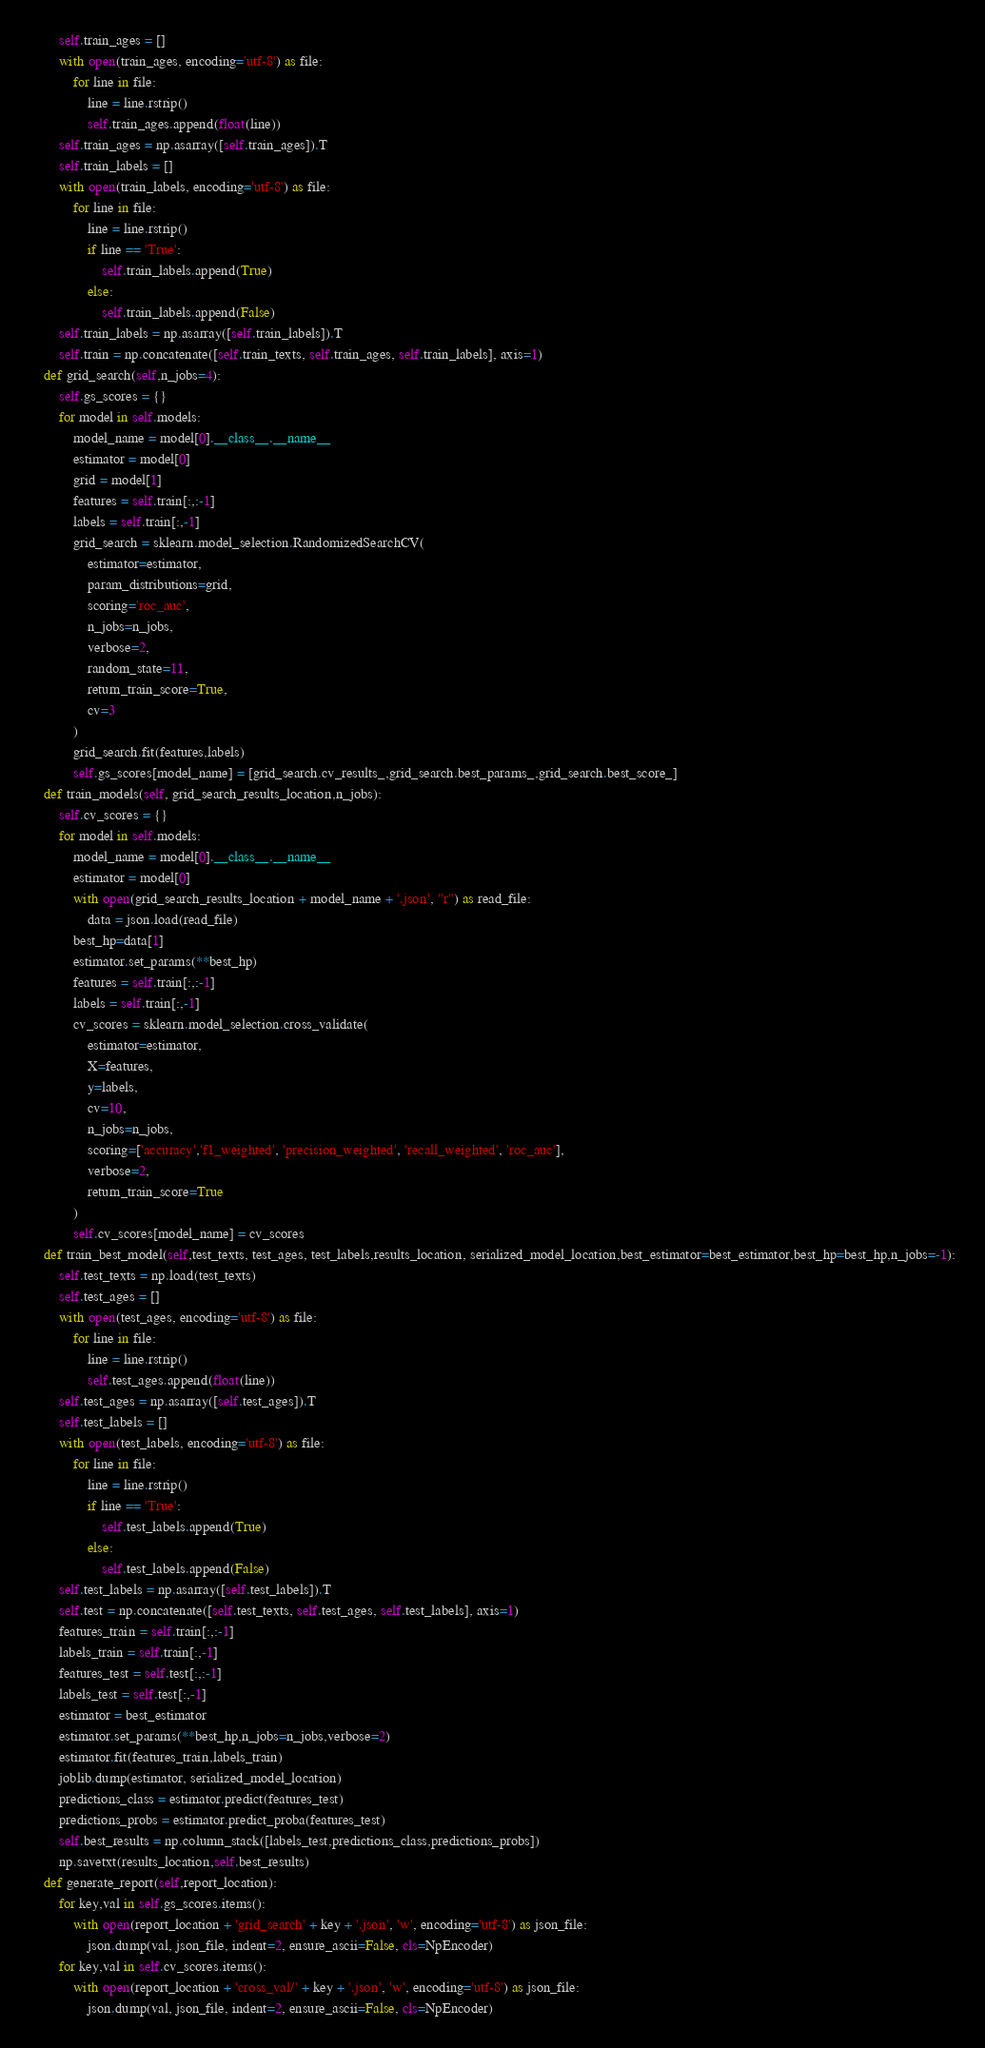Convert code to text. <code><loc_0><loc_0><loc_500><loc_500><_Python_>        self.train_ages = []
        with open(train_ages, encoding='utf-8') as file:
            for line in file:
                line = line.rstrip()
                self.train_ages.append(float(line))
        self.train_ages = np.asarray([self.train_ages]).T
        self.train_labels = []
        with open(train_labels, encoding='utf-8') as file:
            for line in file:
                line = line.rstrip()
                if line == 'True':
                    self.train_labels.append(True)
                else:
                    self.train_labels.append(False)
        self.train_labels = np.asarray([self.train_labels]).T
        self.train = np.concatenate([self.train_texts, self.train_ages, self.train_labels], axis=1)
    def grid_search(self,n_jobs=4):
        self.gs_scores = {}
        for model in self.models:
            model_name = model[0].__class__.__name__
            estimator = model[0]
            grid = model[1]
            features = self.train[:,:-1]
            labels = self.train[:,-1]
            grid_search = sklearn.model_selection.RandomizedSearchCV(
                estimator=estimator,
                param_distributions=grid,
                scoring='roc_auc',
                n_jobs=n_jobs,
                verbose=2,
                random_state=11,
                return_train_score=True,
                cv=3
            )
            grid_search.fit(features,labels)
            self.gs_scores[model_name] = [grid_search.cv_results_,grid_search.best_params_,grid_search.best_score_]
    def train_models(self, grid_search_results_location,n_jobs):
        self.cv_scores = {}
        for model in self.models:
            model_name = model[0].__class__.__name__
            estimator = model[0]
            with open(grid_search_results_location + model_name + '.json', "r") as read_file:
                data = json.load(read_file)
            best_hp=data[1]
            estimator.set_params(**best_hp)
            features = self.train[:,:-1]
            labels = self.train[:,-1]
            cv_scores = sklearn.model_selection.cross_validate(
                estimator=estimator,
                X=features,
                y=labels,
                cv=10,
                n_jobs=n_jobs,
                scoring=['accuracy','f1_weighted', 'precision_weighted', 'recall_weighted', 'roc_auc'],
                verbose=2,
                return_train_score=True
            )
            self.cv_scores[model_name] = cv_scores
    def train_best_model(self,test_texts, test_ages, test_labels,results_location, serialized_model_location,best_estimator=best_estimator,best_hp=best_hp,n_jobs=-1):
        self.test_texts = np.load(test_texts)
        self.test_ages = []
        with open(test_ages, encoding='utf-8') as file:
            for line in file:
                line = line.rstrip()
                self.test_ages.append(float(line))
        self.test_ages = np.asarray([self.test_ages]).T
        self.test_labels = []
        with open(test_labels, encoding='utf-8') as file:
            for line in file:
                line = line.rstrip()
                if line == 'True':
                    self.test_labels.append(True)
                else:
                    self.test_labels.append(False)
        self.test_labels = np.asarray([self.test_labels]).T
        self.test = np.concatenate([self.test_texts, self.test_ages, self.test_labels], axis=1)
        features_train = self.train[:,:-1]
        labels_train = self.train[:,-1]
        features_test = self.test[:,:-1]
        labels_test = self.test[:,-1]
        estimator = best_estimator
        estimator.set_params(**best_hp,n_jobs=n_jobs,verbose=2)
        estimator.fit(features_train,labels_train)
        joblib.dump(estimator, serialized_model_location)
        predictions_class = estimator.predict(features_test)
        predictions_probs = estimator.predict_proba(features_test)
        self.best_results = np.column_stack([labels_test,predictions_class,predictions_probs])
        np.savetxt(results_location,self.best_results)
    def generate_report(self,report_location):
        for key,val in self.gs_scores.items():
            with open(report_location + 'grid_search' + key + '.json', 'w', encoding='utf-8') as json_file:
                json.dump(val, json_file, indent=2, ensure_ascii=False, cls=NpEncoder)
        for key,val in self.cv_scores.items():
            with open(report_location + 'cross_val/' + key + '.json', 'w', encoding='utf-8') as json_file:
                json.dump(val, json_file, indent=2, ensure_ascii=False, cls=NpEncoder)

</code> 